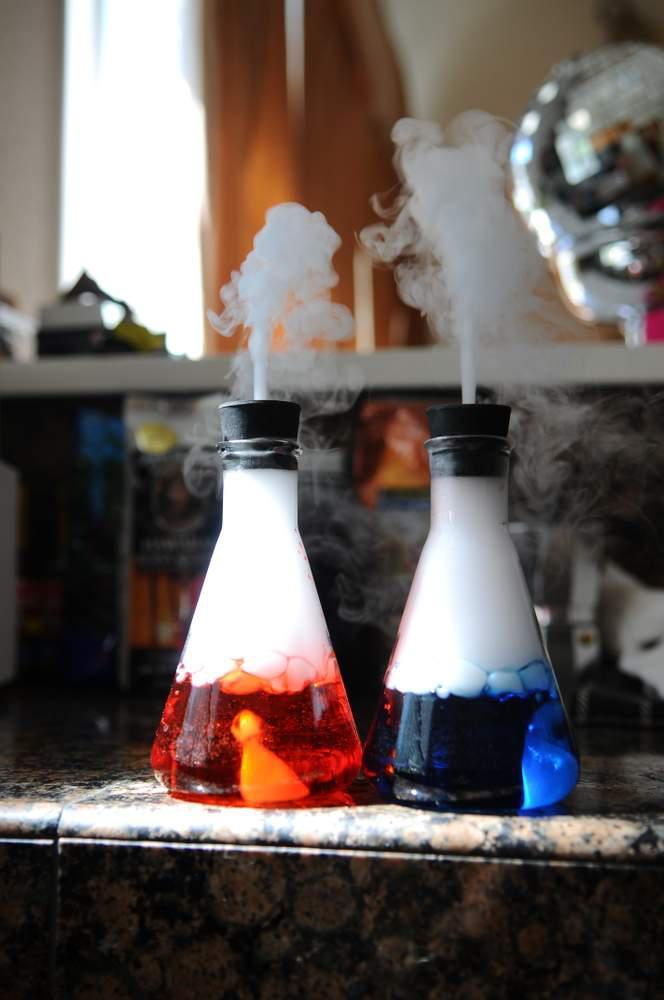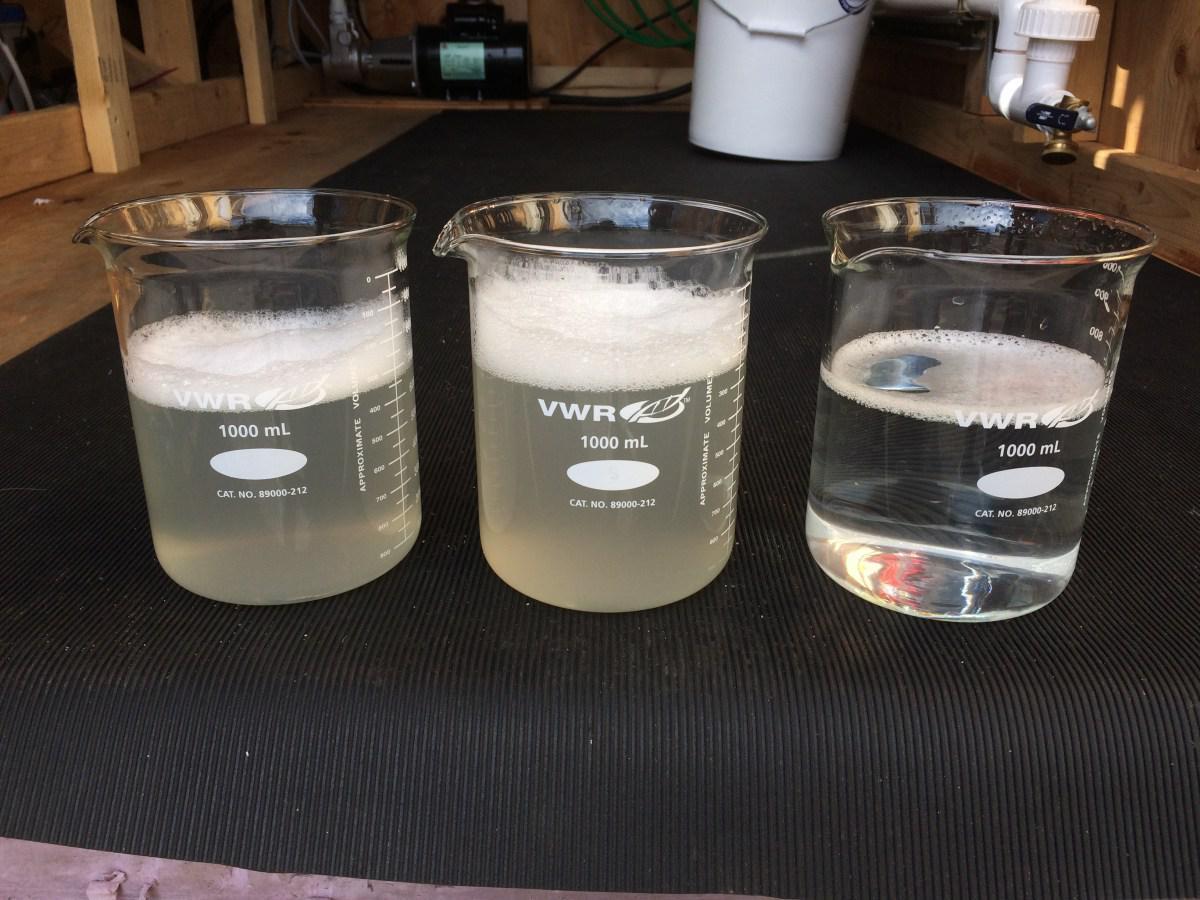The first image is the image on the left, the second image is the image on the right. Assess this claim about the two images: "There appear to be exactly three containers visible.". Correct or not? Answer yes or no. No. 